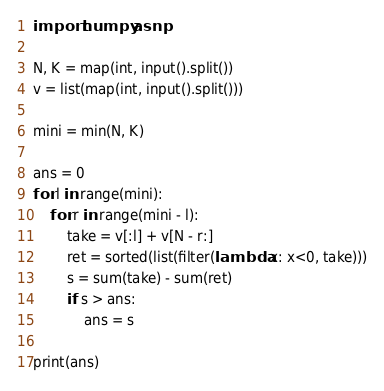Convert code to text. <code><loc_0><loc_0><loc_500><loc_500><_Python_>import numpy as np

N, K = map(int, input().split())
v = list(map(int, input().split()))

mini = min(N, K)

ans = 0
for l in range(mini):
    for r in range(mini - l):
        take = v[:l] + v[N - r:]
        ret = sorted(list(filter(lambda x: x<0, take)))
        s = sum(take) - sum(ret)
        if s > ans:
            ans = s

print(ans)
</code> 